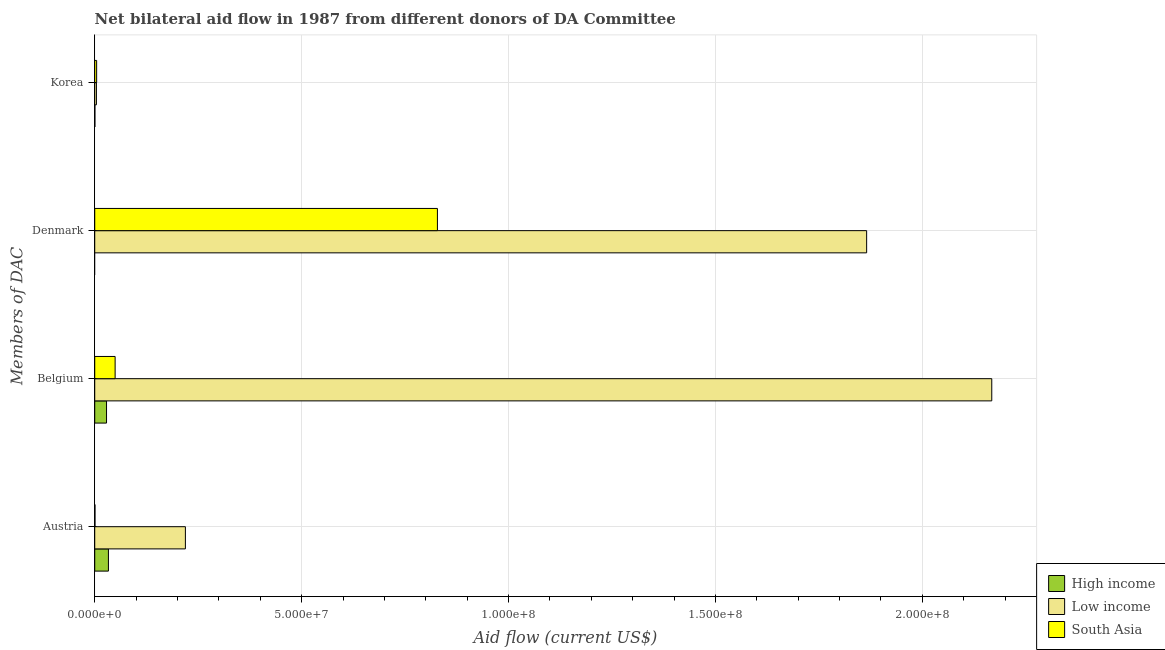How many different coloured bars are there?
Provide a succinct answer. 3. How many groups of bars are there?
Your answer should be very brief. 4. Are the number of bars on each tick of the Y-axis equal?
Offer a terse response. No. How many bars are there on the 1st tick from the top?
Make the answer very short. 3. How many bars are there on the 2nd tick from the bottom?
Make the answer very short. 3. What is the label of the 4th group of bars from the top?
Your response must be concise. Austria. What is the amount of aid given by belgium in High income?
Your response must be concise. 2.85e+06. Across all countries, what is the maximum amount of aid given by belgium?
Your answer should be very brief. 2.17e+08. Across all countries, what is the minimum amount of aid given by belgium?
Make the answer very short. 2.85e+06. What is the total amount of aid given by belgium in the graph?
Your response must be concise. 2.25e+08. What is the difference between the amount of aid given by austria in High income and that in Low income?
Provide a short and direct response. -1.86e+07. What is the difference between the amount of aid given by austria in South Asia and the amount of aid given by korea in Low income?
Provide a succinct answer. -3.50e+05. What is the average amount of aid given by belgium per country?
Provide a short and direct response. 7.49e+07. What is the difference between the amount of aid given by belgium and amount of aid given by austria in South Asia?
Give a very brief answer. 4.87e+06. In how many countries, is the amount of aid given by austria greater than 30000000 US$?
Ensure brevity in your answer.  0. What is the ratio of the amount of aid given by korea in Low income to that in High income?
Offer a terse response. 10.25. Is the difference between the amount of aid given by korea in South Asia and High income greater than the difference between the amount of aid given by austria in South Asia and High income?
Ensure brevity in your answer.  Yes. What is the difference between the highest and the lowest amount of aid given by korea?
Your response must be concise. 4.20e+05. Is the sum of the amount of aid given by austria in Low income and High income greater than the maximum amount of aid given by denmark across all countries?
Your response must be concise. No. Is it the case that in every country, the sum of the amount of aid given by belgium and amount of aid given by korea is greater than the sum of amount of aid given by austria and amount of aid given by denmark?
Provide a succinct answer. No. Is it the case that in every country, the sum of the amount of aid given by austria and amount of aid given by belgium is greater than the amount of aid given by denmark?
Provide a succinct answer. No. Does the graph contain grids?
Provide a short and direct response. Yes. How are the legend labels stacked?
Make the answer very short. Vertical. What is the title of the graph?
Ensure brevity in your answer.  Net bilateral aid flow in 1987 from different donors of DA Committee. Does "Switzerland" appear as one of the legend labels in the graph?
Your answer should be compact. No. What is the label or title of the Y-axis?
Provide a succinct answer. Members of DAC. What is the Aid flow (current US$) of High income in Austria?
Provide a short and direct response. 3.31e+06. What is the Aid flow (current US$) of Low income in Austria?
Give a very brief answer. 2.19e+07. What is the Aid flow (current US$) in South Asia in Austria?
Keep it short and to the point. 6.00e+04. What is the Aid flow (current US$) of High income in Belgium?
Offer a terse response. 2.85e+06. What is the Aid flow (current US$) of Low income in Belgium?
Offer a very short reply. 2.17e+08. What is the Aid flow (current US$) in South Asia in Belgium?
Your answer should be compact. 4.93e+06. What is the Aid flow (current US$) in High income in Denmark?
Provide a short and direct response. 0. What is the Aid flow (current US$) in Low income in Denmark?
Your answer should be very brief. 1.87e+08. What is the Aid flow (current US$) in South Asia in Denmark?
Provide a short and direct response. 8.28e+07. What is the Aid flow (current US$) in South Asia in Korea?
Give a very brief answer. 4.60e+05. Across all Members of DAC, what is the maximum Aid flow (current US$) in High income?
Make the answer very short. 3.31e+06. Across all Members of DAC, what is the maximum Aid flow (current US$) of Low income?
Your response must be concise. 2.17e+08. Across all Members of DAC, what is the maximum Aid flow (current US$) of South Asia?
Your answer should be compact. 8.28e+07. Across all Members of DAC, what is the minimum Aid flow (current US$) in Low income?
Make the answer very short. 4.10e+05. Across all Members of DAC, what is the minimum Aid flow (current US$) of South Asia?
Keep it short and to the point. 6.00e+04. What is the total Aid flow (current US$) of High income in the graph?
Give a very brief answer. 6.20e+06. What is the total Aid flow (current US$) in Low income in the graph?
Your answer should be compact. 4.26e+08. What is the total Aid flow (current US$) in South Asia in the graph?
Ensure brevity in your answer.  8.83e+07. What is the difference between the Aid flow (current US$) of High income in Austria and that in Belgium?
Keep it short and to the point. 4.60e+05. What is the difference between the Aid flow (current US$) in Low income in Austria and that in Belgium?
Offer a very short reply. -1.95e+08. What is the difference between the Aid flow (current US$) of South Asia in Austria and that in Belgium?
Ensure brevity in your answer.  -4.87e+06. What is the difference between the Aid flow (current US$) of Low income in Austria and that in Denmark?
Keep it short and to the point. -1.65e+08. What is the difference between the Aid flow (current US$) of South Asia in Austria and that in Denmark?
Offer a terse response. -8.28e+07. What is the difference between the Aid flow (current US$) of High income in Austria and that in Korea?
Offer a very short reply. 3.27e+06. What is the difference between the Aid flow (current US$) of Low income in Austria and that in Korea?
Give a very brief answer. 2.15e+07. What is the difference between the Aid flow (current US$) in South Asia in Austria and that in Korea?
Your response must be concise. -4.00e+05. What is the difference between the Aid flow (current US$) of Low income in Belgium and that in Denmark?
Ensure brevity in your answer.  3.02e+07. What is the difference between the Aid flow (current US$) of South Asia in Belgium and that in Denmark?
Offer a terse response. -7.79e+07. What is the difference between the Aid flow (current US$) in High income in Belgium and that in Korea?
Offer a very short reply. 2.81e+06. What is the difference between the Aid flow (current US$) of Low income in Belgium and that in Korea?
Make the answer very short. 2.16e+08. What is the difference between the Aid flow (current US$) of South Asia in Belgium and that in Korea?
Your response must be concise. 4.47e+06. What is the difference between the Aid flow (current US$) of Low income in Denmark and that in Korea?
Provide a short and direct response. 1.86e+08. What is the difference between the Aid flow (current US$) of South Asia in Denmark and that in Korea?
Ensure brevity in your answer.  8.24e+07. What is the difference between the Aid flow (current US$) in High income in Austria and the Aid flow (current US$) in Low income in Belgium?
Provide a succinct answer. -2.13e+08. What is the difference between the Aid flow (current US$) of High income in Austria and the Aid flow (current US$) of South Asia in Belgium?
Your answer should be compact. -1.62e+06. What is the difference between the Aid flow (current US$) in Low income in Austria and the Aid flow (current US$) in South Asia in Belgium?
Offer a very short reply. 1.70e+07. What is the difference between the Aid flow (current US$) of High income in Austria and the Aid flow (current US$) of Low income in Denmark?
Provide a short and direct response. -1.83e+08. What is the difference between the Aid flow (current US$) of High income in Austria and the Aid flow (current US$) of South Asia in Denmark?
Offer a terse response. -7.95e+07. What is the difference between the Aid flow (current US$) in Low income in Austria and the Aid flow (current US$) in South Asia in Denmark?
Your answer should be compact. -6.09e+07. What is the difference between the Aid flow (current US$) in High income in Austria and the Aid flow (current US$) in Low income in Korea?
Give a very brief answer. 2.90e+06. What is the difference between the Aid flow (current US$) of High income in Austria and the Aid flow (current US$) of South Asia in Korea?
Make the answer very short. 2.85e+06. What is the difference between the Aid flow (current US$) of Low income in Austria and the Aid flow (current US$) of South Asia in Korea?
Your response must be concise. 2.14e+07. What is the difference between the Aid flow (current US$) of High income in Belgium and the Aid flow (current US$) of Low income in Denmark?
Your answer should be compact. -1.84e+08. What is the difference between the Aid flow (current US$) of High income in Belgium and the Aid flow (current US$) of South Asia in Denmark?
Offer a very short reply. -8.00e+07. What is the difference between the Aid flow (current US$) of Low income in Belgium and the Aid flow (current US$) of South Asia in Denmark?
Keep it short and to the point. 1.34e+08. What is the difference between the Aid flow (current US$) of High income in Belgium and the Aid flow (current US$) of Low income in Korea?
Provide a succinct answer. 2.44e+06. What is the difference between the Aid flow (current US$) of High income in Belgium and the Aid flow (current US$) of South Asia in Korea?
Your answer should be compact. 2.39e+06. What is the difference between the Aid flow (current US$) in Low income in Belgium and the Aid flow (current US$) in South Asia in Korea?
Your answer should be compact. 2.16e+08. What is the difference between the Aid flow (current US$) in Low income in Denmark and the Aid flow (current US$) in South Asia in Korea?
Offer a very short reply. 1.86e+08. What is the average Aid flow (current US$) in High income per Members of DAC?
Give a very brief answer. 1.55e+06. What is the average Aid flow (current US$) in Low income per Members of DAC?
Keep it short and to the point. 1.06e+08. What is the average Aid flow (current US$) of South Asia per Members of DAC?
Your response must be concise. 2.21e+07. What is the difference between the Aid flow (current US$) in High income and Aid flow (current US$) in Low income in Austria?
Keep it short and to the point. -1.86e+07. What is the difference between the Aid flow (current US$) in High income and Aid flow (current US$) in South Asia in Austria?
Your response must be concise. 3.25e+06. What is the difference between the Aid flow (current US$) of Low income and Aid flow (current US$) of South Asia in Austria?
Provide a short and direct response. 2.18e+07. What is the difference between the Aid flow (current US$) of High income and Aid flow (current US$) of Low income in Belgium?
Give a very brief answer. -2.14e+08. What is the difference between the Aid flow (current US$) in High income and Aid flow (current US$) in South Asia in Belgium?
Provide a succinct answer. -2.08e+06. What is the difference between the Aid flow (current US$) in Low income and Aid flow (current US$) in South Asia in Belgium?
Provide a succinct answer. 2.12e+08. What is the difference between the Aid flow (current US$) of Low income and Aid flow (current US$) of South Asia in Denmark?
Give a very brief answer. 1.04e+08. What is the difference between the Aid flow (current US$) of High income and Aid flow (current US$) of Low income in Korea?
Offer a terse response. -3.70e+05. What is the difference between the Aid flow (current US$) of High income and Aid flow (current US$) of South Asia in Korea?
Your response must be concise. -4.20e+05. What is the ratio of the Aid flow (current US$) in High income in Austria to that in Belgium?
Keep it short and to the point. 1.16. What is the ratio of the Aid flow (current US$) of Low income in Austria to that in Belgium?
Your answer should be compact. 0.1. What is the ratio of the Aid flow (current US$) in South Asia in Austria to that in Belgium?
Ensure brevity in your answer.  0.01. What is the ratio of the Aid flow (current US$) of Low income in Austria to that in Denmark?
Provide a short and direct response. 0.12. What is the ratio of the Aid flow (current US$) in South Asia in Austria to that in Denmark?
Give a very brief answer. 0. What is the ratio of the Aid flow (current US$) in High income in Austria to that in Korea?
Your answer should be compact. 82.75. What is the ratio of the Aid flow (current US$) in Low income in Austria to that in Korea?
Provide a short and direct response. 53.44. What is the ratio of the Aid flow (current US$) in South Asia in Austria to that in Korea?
Your answer should be very brief. 0.13. What is the ratio of the Aid flow (current US$) in Low income in Belgium to that in Denmark?
Ensure brevity in your answer.  1.16. What is the ratio of the Aid flow (current US$) of South Asia in Belgium to that in Denmark?
Offer a very short reply. 0.06. What is the ratio of the Aid flow (current US$) of High income in Belgium to that in Korea?
Provide a short and direct response. 71.25. What is the ratio of the Aid flow (current US$) of Low income in Belgium to that in Korea?
Provide a succinct answer. 528.76. What is the ratio of the Aid flow (current US$) of South Asia in Belgium to that in Korea?
Provide a short and direct response. 10.72. What is the ratio of the Aid flow (current US$) of Low income in Denmark to that in Korea?
Make the answer very short. 455. What is the ratio of the Aid flow (current US$) of South Asia in Denmark to that in Korea?
Make the answer very short. 180.04. What is the difference between the highest and the second highest Aid flow (current US$) in Low income?
Make the answer very short. 3.02e+07. What is the difference between the highest and the second highest Aid flow (current US$) in South Asia?
Make the answer very short. 7.79e+07. What is the difference between the highest and the lowest Aid flow (current US$) in High income?
Your answer should be compact. 3.31e+06. What is the difference between the highest and the lowest Aid flow (current US$) of Low income?
Offer a very short reply. 2.16e+08. What is the difference between the highest and the lowest Aid flow (current US$) of South Asia?
Make the answer very short. 8.28e+07. 